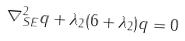<formula> <loc_0><loc_0><loc_500><loc_500>\nabla _ { S E } ^ { 2 } q + \lambda _ { 2 } ( 6 + \lambda _ { 2 } ) q = 0</formula> 